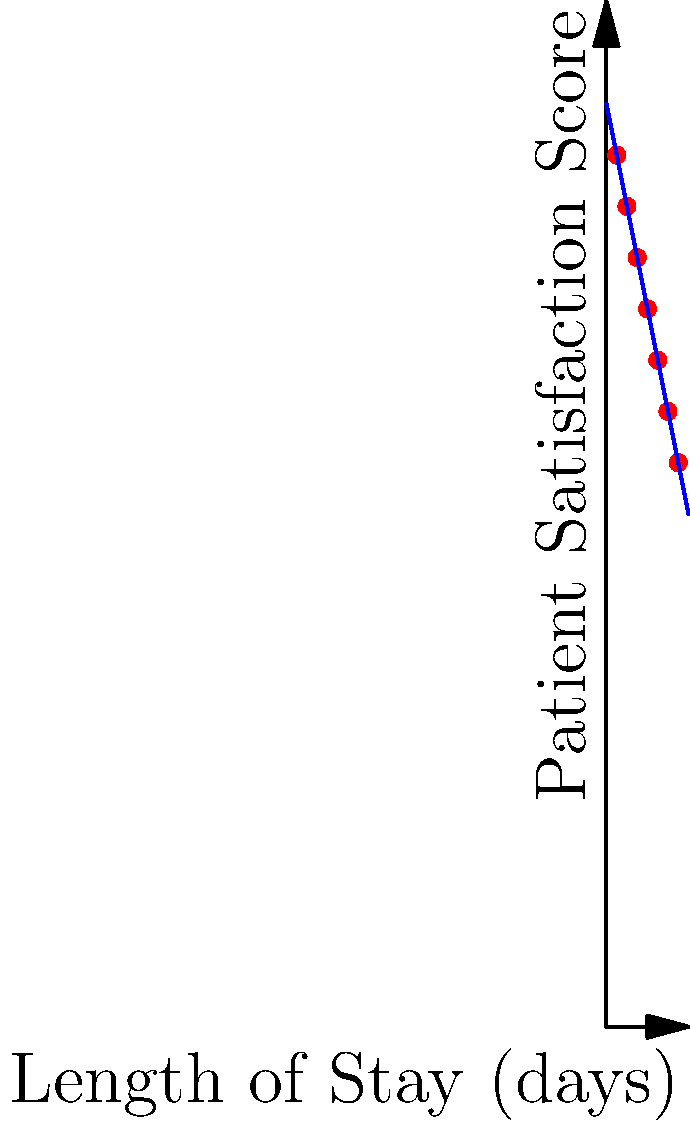Based on the scatter plot of patient satisfaction scores against length of stay, what is the approximate rate of decline in patient satisfaction score per day of hospital stay? To determine the rate of decline in patient satisfaction score per day of hospital stay, we need to analyze the trend in the scatter plot:

1. Observe that there is a clear negative correlation between length of stay and patient satisfaction score.

2. The blue line represents the best fit line for the data points.

3. To calculate the rate of decline, we need to determine the slope of this line.

4. We can estimate the slope by choosing two points on the line:
   - At x = 0 (y-intercept), y ≈ 90
   - At x = 8, y ≈ 50

5. Calculate the slope:
   $\text{Slope} = \frac{y_2 - y_1}{x_2 - x_1} = \frac{50 - 90}{8 - 0} = \frac{-40}{8} = -5$

6. The negative slope indicates a decline, and its magnitude represents the rate of decline per unit of x (days in this case).

Therefore, the patient satisfaction score decreases by approximately 5 points per day of hospital stay.
Answer: 5 points per day 